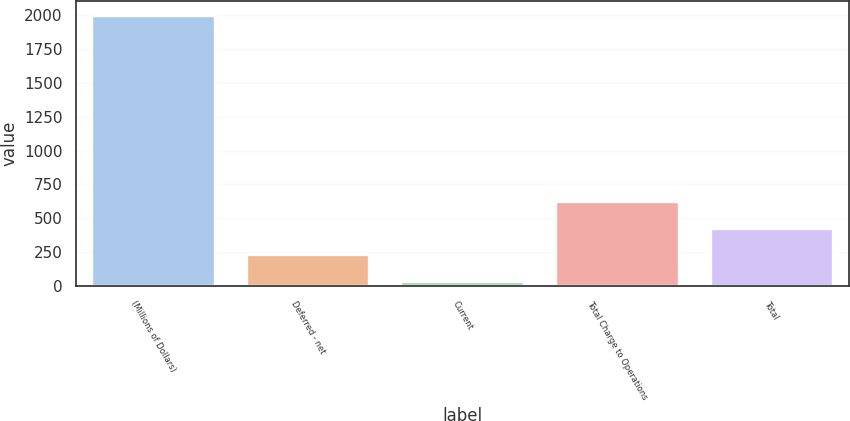Convert chart to OTSL. <chart><loc_0><loc_0><loc_500><loc_500><bar_chart><fcel>(Millions of Dollars)<fcel>Deferred - net<fcel>Current<fcel>Total Charge to Operations<fcel>Total<nl><fcel>2003<fcel>232.7<fcel>36<fcel>626.1<fcel>429.4<nl></chart> 